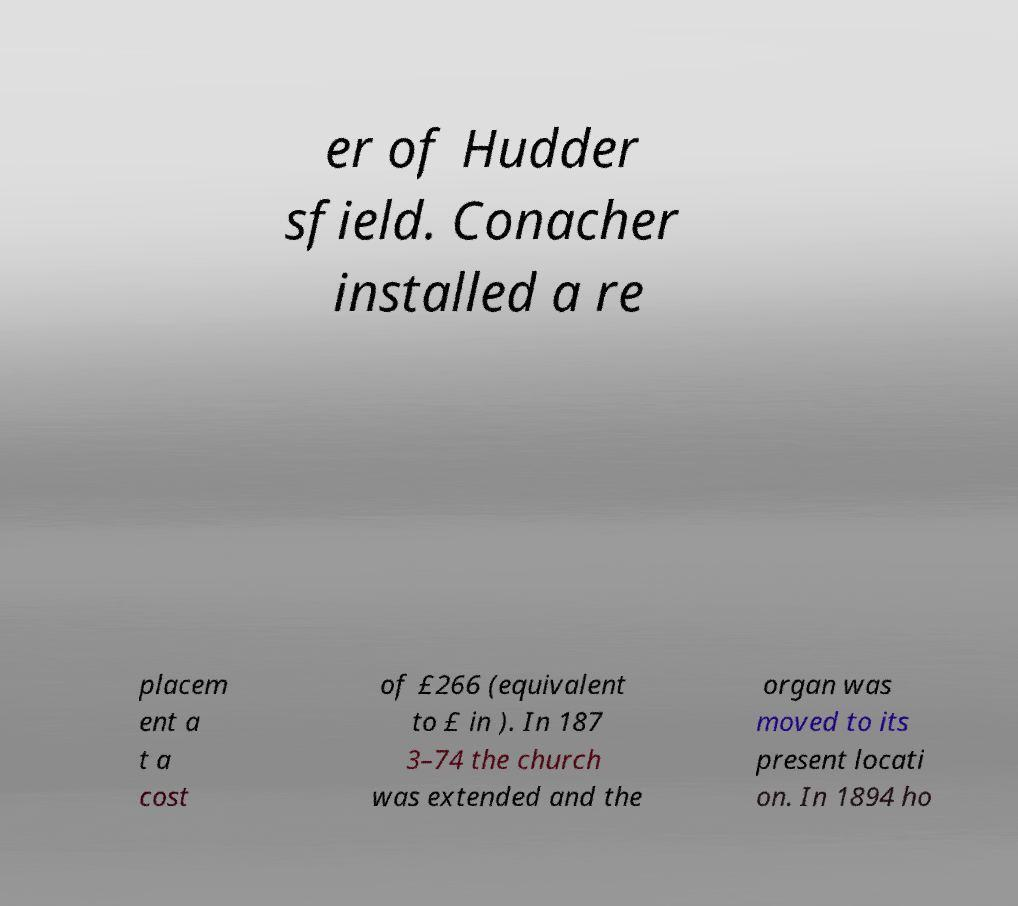Can you accurately transcribe the text from the provided image for me? er of Hudder sfield. Conacher installed a re placem ent a t a cost of £266 (equivalent to £ in ). In 187 3–74 the church was extended and the organ was moved to its present locati on. In 1894 ho 